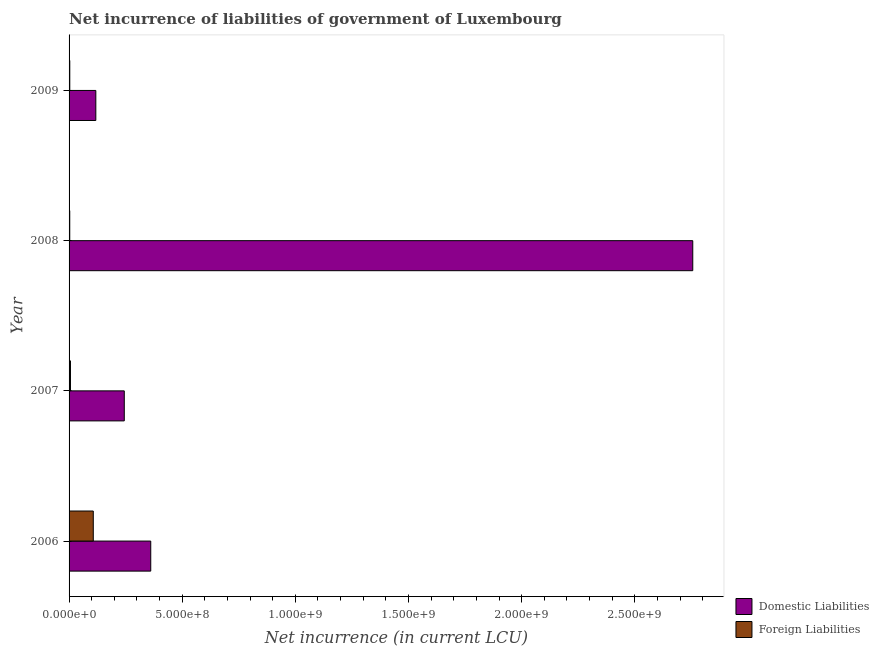How many different coloured bars are there?
Your answer should be very brief. 2. How many groups of bars are there?
Your answer should be compact. 4. Are the number of bars per tick equal to the number of legend labels?
Ensure brevity in your answer.  Yes. How many bars are there on the 1st tick from the bottom?
Ensure brevity in your answer.  2. What is the label of the 4th group of bars from the top?
Provide a short and direct response. 2006. In how many cases, is the number of bars for a given year not equal to the number of legend labels?
Provide a succinct answer. 0. What is the net incurrence of foreign liabilities in 2007?
Offer a very short reply. 6.20e+06. Across all years, what is the maximum net incurrence of domestic liabilities?
Your answer should be very brief. 2.76e+09. Across all years, what is the minimum net incurrence of domestic liabilities?
Provide a short and direct response. 1.18e+08. What is the total net incurrence of foreign liabilities in the graph?
Keep it short and to the point. 1.19e+08. What is the difference between the net incurrence of domestic liabilities in 2006 and that in 2008?
Offer a very short reply. -2.40e+09. What is the difference between the net incurrence of domestic liabilities in 2009 and the net incurrence of foreign liabilities in 2006?
Ensure brevity in your answer.  1.12e+07. What is the average net incurrence of domestic liabilities per year?
Keep it short and to the point. 8.70e+08. In the year 2006, what is the difference between the net incurrence of domestic liabilities and net incurrence of foreign liabilities?
Offer a very short reply. 2.54e+08. What is the ratio of the net incurrence of foreign liabilities in 2008 to that in 2009?
Provide a short and direct response. 0.95. Is the net incurrence of domestic liabilities in 2008 less than that in 2009?
Your answer should be very brief. No. Is the difference between the net incurrence of domestic liabilities in 2006 and 2008 greater than the difference between the net incurrence of foreign liabilities in 2006 and 2008?
Offer a terse response. No. What is the difference between the highest and the second highest net incurrence of foreign liabilities?
Keep it short and to the point. 1.01e+08. What is the difference between the highest and the lowest net incurrence of foreign liabilities?
Your answer should be very brief. 1.04e+08. What does the 2nd bar from the top in 2007 represents?
Ensure brevity in your answer.  Domestic Liabilities. What does the 2nd bar from the bottom in 2009 represents?
Provide a succinct answer. Foreign Liabilities. Are all the bars in the graph horizontal?
Your answer should be compact. Yes. How many years are there in the graph?
Keep it short and to the point. 4. What is the difference between two consecutive major ticks on the X-axis?
Offer a very short reply. 5.00e+08. Are the values on the major ticks of X-axis written in scientific E-notation?
Your answer should be compact. Yes. Does the graph contain any zero values?
Provide a short and direct response. No. Does the graph contain grids?
Offer a terse response. No. How many legend labels are there?
Give a very brief answer. 2. How are the legend labels stacked?
Offer a very short reply. Vertical. What is the title of the graph?
Your response must be concise. Net incurrence of liabilities of government of Luxembourg. What is the label or title of the X-axis?
Provide a short and direct response. Net incurrence (in current LCU). What is the label or title of the Y-axis?
Provide a short and direct response. Year. What is the Net incurrence (in current LCU) in Domestic Liabilities in 2006?
Provide a succinct answer. 3.61e+08. What is the Net incurrence (in current LCU) of Foreign Liabilities in 2006?
Provide a succinct answer. 1.07e+08. What is the Net incurrence (in current LCU) in Domestic Liabilities in 2007?
Your answer should be compact. 2.44e+08. What is the Net incurrence (in current LCU) of Foreign Liabilities in 2007?
Provide a succinct answer. 6.20e+06. What is the Net incurrence (in current LCU) in Domestic Liabilities in 2008?
Your response must be concise. 2.76e+09. What is the Net incurrence (in current LCU) in Domestic Liabilities in 2009?
Your answer should be compact. 1.18e+08. What is the Net incurrence (in current LCU) of Foreign Liabilities in 2009?
Offer a terse response. 3.16e+06. Across all years, what is the maximum Net incurrence (in current LCU) in Domestic Liabilities?
Provide a short and direct response. 2.76e+09. Across all years, what is the maximum Net incurrence (in current LCU) in Foreign Liabilities?
Give a very brief answer. 1.07e+08. Across all years, what is the minimum Net incurrence (in current LCU) of Domestic Liabilities?
Provide a succinct answer. 1.18e+08. What is the total Net incurrence (in current LCU) of Domestic Liabilities in the graph?
Ensure brevity in your answer.  3.48e+09. What is the total Net incurrence (in current LCU) of Foreign Liabilities in the graph?
Give a very brief answer. 1.19e+08. What is the difference between the Net incurrence (in current LCU) of Domestic Liabilities in 2006 and that in 2007?
Offer a very short reply. 1.17e+08. What is the difference between the Net incurrence (in current LCU) of Foreign Liabilities in 2006 and that in 2007?
Give a very brief answer. 1.01e+08. What is the difference between the Net incurrence (in current LCU) of Domestic Liabilities in 2006 and that in 2008?
Provide a short and direct response. -2.40e+09. What is the difference between the Net incurrence (in current LCU) in Foreign Liabilities in 2006 and that in 2008?
Offer a terse response. 1.04e+08. What is the difference between the Net incurrence (in current LCU) in Domestic Liabilities in 2006 and that in 2009?
Your response must be concise. 2.43e+08. What is the difference between the Net incurrence (in current LCU) of Foreign Liabilities in 2006 and that in 2009?
Keep it short and to the point. 1.04e+08. What is the difference between the Net incurrence (in current LCU) in Domestic Liabilities in 2007 and that in 2008?
Offer a terse response. -2.51e+09. What is the difference between the Net incurrence (in current LCU) of Foreign Liabilities in 2007 and that in 2008?
Your response must be concise. 3.20e+06. What is the difference between the Net incurrence (in current LCU) of Domestic Liabilities in 2007 and that in 2009?
Offer a terse response. 1.26e+08. What is the difference between the Net incurrence (in current LCU) of Foreign Liabilities in 2007 and that in 2009?
Make the answer very short. 3.04e+06. What is the difference between the Net incurrence (in current LCU) in Domestic Liabilities in 2008 and that in 2009?
Offer a very short reply. 2.64e+09. What is the difference between the Net incurrence (in current LCU) in Foreign Liabilities in 2008 and that in 2009?
Your answer should be very brief. -1.57e+05. What is the difference between the Net incurrence (in current LCU) of Domestic Liabilities in 2006 and the Net incurrence (in current LCU) of Foreign Liabilities in 2007?
Your answer should be compact. 3.55e+08. What is the difference between the Net incurrence (in current LCU) in Domestic Liabilities in 2006 and the Net incurrence (in current LCU) in Foreign Liabilities in 2008?
Your answer should be compact. 3.58e+08. What is the difference between the Net incurrence (in current LCU) in Domestic Liabilities in 2006 and the Net incurrence (in current LCU) in Foreign Liabilities in 2009?
Make the answer very short. 3.58e+08. What is the difference between the Net incurrence (in current LCU) of Domestic Liabilities in 2007 and the Net incurrence (in current LCU) of Foreign Liabilities in 2008?
Your answer should be compact. 2.41e+08. What is the difference between the Net incurrence (in current LCU) of Domestic Liabilities in 2007 and the Net incurrence (in current LCU) of Foreign Liabilities in 2009?
Give a very brief answer. 2.41e+08. What is the difference between the Net incurrence (in current LCU) of Domestic Liabilities in 2008 and the Net incurrence (in current LCU) of Foreign Liabilities in 2009?
Ensure brevity in your answer.  2.75e+09. What is the average Net incurrence (in current LCU) in Domestic Liabilities per year?
Offer a very short reply. 8.70e+08. What is the average Net incurrence (in current LCU) of Foreign Liabilities per year?
Ensure brevity in your answer.  2.98e+07. In the year 2006, what is the difference between the Net incurrence (in current LCU) of Domestic Liabilities and Net incurrence (in current LCU) of Foreign Liabilities?
Provide a short and direct response. 2.54e+08. In the year 2007, what is the difference between the Net incurrence (in current LCU) of Domestic Liabilities and Net incurrence (in current LCU) of Foreign Liabilities?
Your answer should be compact. 2.38e+08. In the year 2008, what is the difference between the Net incurrence (in current LCU) of Domestic Liabilities and Net incurrence (in current LCU) of Foreign Liabilities?
Provide a short and direct response. 2.75e+09. In the year 2009, what is the difference between the Net incurrence (in current LCU) of Domestic Liabilities and Net incurrence (in current LCU) of Foreign Liabilities?
Ensure brevity in your answer.  1.15e+08. What is the ratio of the Net incurrence (in current LCU) of Domestic Liabilities in 2006 to that in 2007?
Your answer should be very brief. 1.48. What is the ratio of the Net incurrence (in current LCU) of Foreign Liabilities in 2006 to that in 2007?
Your answer should be very brief. 17.26. What is the ratio of the Net incurrence (in current LCU) in Domestic Liabilities in 2006 to that in 2008?
Ensure brevity in your answer.  0.13. What is the ratio of the Net incurrence (in current LCU) of Foreign Liabilities in 2006 to that in 2008?
Provide a short and direct response. 35.67. What is the ratio of the Net incurrence (in current LCU) of Domestic Liabilities in 2006 to that in 2009?
Offer a very short reply. 3.05. What is the ratio of the Net incurrence (in current LCU) in Foreign Liabilities in 2006 to that in 2009?
Your answer should be compact. 33.89. What is the ratio of the Net incurrence (in current LCU) in Domestic Liabilities in 2007 to that in 2008?
Offer a very short reply. 0.09. What is the ratio of the Net incurrence (in current LCU) of Foreign Liabilities in 2007 to that in 2008?
Ensure brevity in your answer.  2.07. What is the ratio of the Net incurrence (in current LCU) of Domestic Liabilities in 2007 to that in 2009?
Provide a short and direct response. 2.06. What is the ratio of the Net incurrence (in current LCU) of Foreign Liabilities in 2007 to that in 2009?
Your answer should be compact. 1.96. What is the ratio of the Net incurrence (in current LCU) in Domestic Liabilities in 2008 to that in 2009?
Offer a terse response. 23.31. What is the ratio of the Net incurrence (in current LCU) in Foreign Liabilities in 2008 to that in 2009?
Your answer should be compact. 0.95. What is the difference between the highest and the second highest Net incurrence (in current LCU) in Domestic Liabilities?
Your response must be concise. 2.40e+09. What is the difference between the highest and the second highest Net incurrence (in current LCU) of Foreign Liabilities?
Provide a short and direct response. 1.01e+08. What is the difference between the highest and the lowest Net incurrence (in current LCU) of Domestic Liabilities?
Ensure brevity in your answer.  2.64e+09. What is the difference between the highest and the lowest Net incurrence (in current LCU) in Foreign Liabilities?
Your response must be concise. 1.04e+08. 